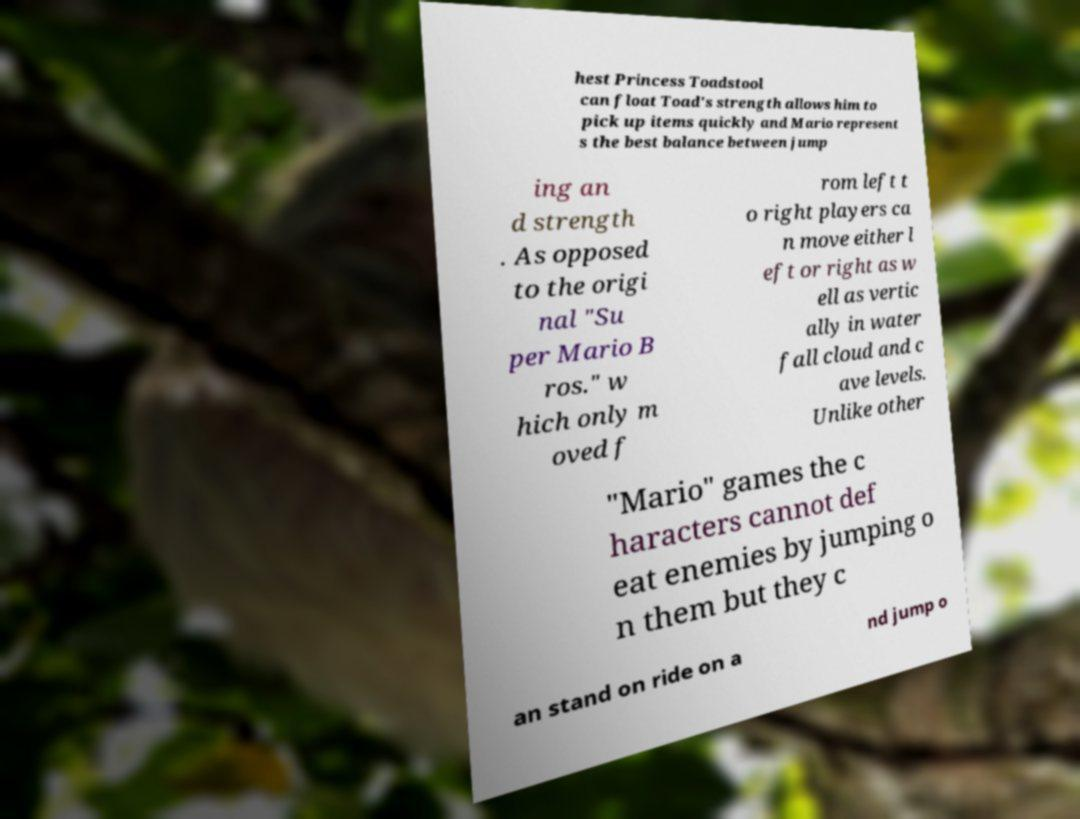Could you assist in decoding the text presented in this image and type it out clearly? hest Princess Toadstool can float Toad's strength allows him to pick up items quickly and Mario represent s the best balance between jump ing an d strength . As opposed to the origi nal "Su per Mario B ros." w hich only m oved f rom left t o right players ca n move either l eft or right as w ell as vertic ally in water fall cloud and c ave levels. Unlike other "Mario" games the c haracters cannot def eat enemies by jumping o n them but they c an stand on ride on a nd jump o 